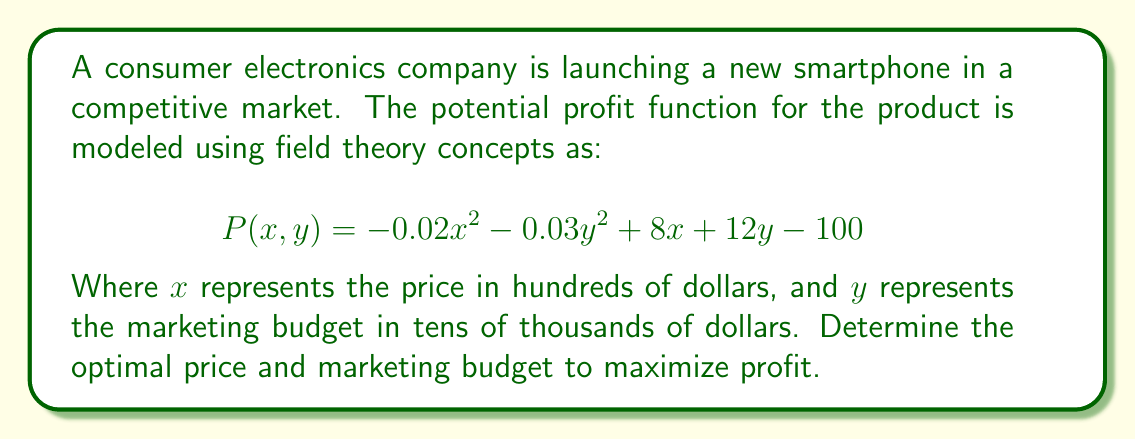Give your solution to this math problem. To find the optimal price and marketing budget, we need to find the critical points of the profit function $P(x, y)$. This involves taking partial derivatives with respect to $x$ and $y$, setting them equal to zero, and solving the resulting system of equations.

Step 1: Calculate partial derivatives
$$\frac{\partial P}{\partial x} = -0.04x + 8$$
$$\frac{\partial P}{\partial y} = -0.06y + 12$$

Step 2: Set partial derivatives to zero
$$-0.04x + 8 = 0$$
$$-0.06y + 12 = 0$$

Step 3: Solve the system of equations
From $-0.04x + 8 = 0$:
$$x = \frac{8}{0.04} = 200$$

From $-0.06y + 12 = 0$:
$$y = \frac{12}{0.06} = 200$$

Step 4: Verify that this critical point is a maximum
Calculate the second partial derivatives:
$$\frac{\partial^2 P}{\partial x^2} = -0.04$$
$$\frac{\partial^2 P}{\partial y^2} = -0.06$$
$$\frac{\partial^2 P}{\partial x \partial y} = \frac{\partial^2 P}{\partial y \partial x} = 0$$

The Hessian matrix is:
$$H = \begin{bmatrix} -0.04 & 0 \\ 0 & -0.06 \end{bmatrix}$$

Since both second partial derivatives are negative and the determinant of the Hessian is positive, this critical point is a local maximum.

Step 5: Interpret the results
The optimal price $x = 200$ represents $200 * 100 = $20,000$
The optimal marketing budget $y = 200$ represents $200 * 10,000 = $2,000,000$
Answer: Optimal price: $20,000; Optimal marketing budget: $2,000,000 